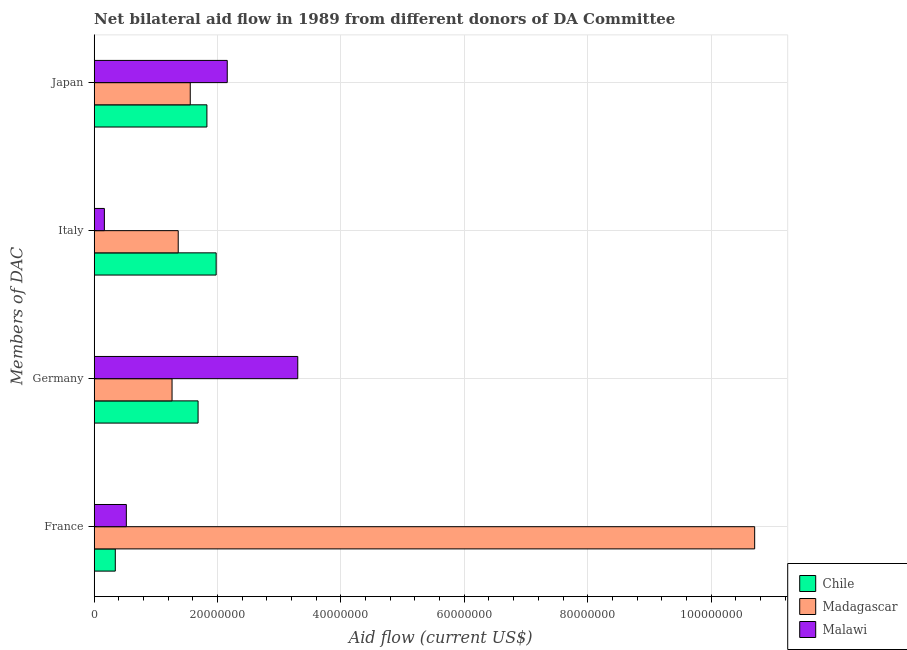Are the number of bars per tick equal to the number of legend labels?
Your answer should be very brief. Yes. What is the label of the 3rd group of bars from the top?
Your answer should be very brief. Germany. What is the amount of aid given by italy in Chile?
Your answer should be very brief. 1.98e+07. Across all countries, what is the maximum amount of aid given by japan?
Your answer should be compact. 2.16e+07. Across all countries, what is the minimum amount of aid given by japan?
Give a very brief answer. 1.56e+07. In which country was the amount of aid given by germany minimum?
Make the answer very short. Madagascar. What is the total amount of aid given by germany in the graph?
Give a very brief answer. 6.25e+07. What is the difference between the amount of aid given by france in Madagascar and that in Chile?
Offer a very short reply. 1.04e+08. What is the difference between the amount of aid given by japan in Madagascar and the amount of aid given by france in Chile?
Offer a very short reply. 1.22e+07. What is the average amount of aid given by germany per country?
Your response must be concise. 2.08e+07. What is the difference between the amount of aid given by france and amount of aid given by germany in Chile?
Make the answer very short. -1.34e+07. What is the ratio of the amount of aid given by japan in Chile to that in Malawi?
Give a very brief answer. 0.85. Is the amount of aid given by germany in Madagascar less than that in Malawi?
Keep it short and to the point. Yes. Is the difference between the amount of aid given by france in Chile and Malawi greater than the difference between the amount of aid given by japan in Chile and Malawi?
Your answer should be compact. Yes. What is the difference between the highest and the second highest amount of aid given by italy?
Offer a terse response. 6.15e+06. What is the difference between the highest and the lowest amount of aid given by france?
Provide a short and direct response. 1.04e+08. Is the sum of the amount of aid given by germany in Chile and Madagascar greater than the maximum amount of aid given by france across all countries?
Make the answer very short. No. Is it the case that in every country, the sum of the amount of aid given by france and amount of aid given by germany is greater than the sum of amount of aid given by italy and amount of aid given by japan?
Provide a succinct answer. No. What does the 1st bar from the top in Germany represents?
Keep it short and to the point. Malawi. What does the 2nd bar from the bottom in Germany represents?
Ensure brevity in your answer.  Madagascar. Is it the case that in every country, the sum of the amount of aid given by france and amount of aid given by germany is greater than the amount of aid given by italy?
Your answer should be compact. Yes. How many bars are there?
Keep it short and to the point. 12. How many countries are there in the graph?
Ensure brevity in your answer.  3. What is the difference between two consecutive major ticks on the X-axis?
Your response must be concise. 2.00e+07. Does the graph contain any zero values?
Offer a terse response. No. Does the graph contain grids?
Your answer should be very brief. Yes. How many legend labels are there?
Provide a succinct answer. 3. How are the legend labels stacked?
Offer a very short reply. Vertical. What is the title of the graph?
Keep it short and to the point. Net bilateral aid flow in 1989 from different donors of DA Committee. What is the label or title of the Y-axis?
Keep it short and to the point. Members of DAC. What is the Aid flow (current US$) of Chile in France?
Provide a short and direct response. 3.42e+06. What is the Aid flow (current US$) in Madagascar in France?
Offer a terse response. 1.07e+08. What is the Aid flow (current US$) of Malawi in France?
Keep it short and to the point. 5.21e+06. What is the Aid flow (current US$) in Chile in Germany?
Ensure brevity in your answer.  1.68e+07. What is the Aid flow (current US$) of Madagascar in Germany?
Offer a very short reply. 1.26e+07. What is the Aid flow (current US$) of Malawi in Germany?
Provide a succinct answer. 3.30e+07. What is the Aid flow (current US$) in Chile in Italy?
Your answer should be compact. 1.98e+07. What is the Aid flow (current US$) in Madagascar in Italy?
Provide a short and direct response. 1.36e+07. What is the Aid flow (current US$) of Malawi in Italy?
Offer a terse response. 1.65e+06. What is the Aid flow (current US$) in Chile in Japan?
Offer a very short reply. 1.83e+07. What is the Aid flow (current US$) of Madagascar in Japan?
Your response must be concise. 1.56e+07. What is the Aid flow (current US$) of Malawi in Japan?
Provide a succinct answer. 2.16e+07. Across all Members of DAC, what is the maximum Aid flow (current US$) in Chile?
Make the answer very short. 1.98e+07. Across all Members of DAC, what is the maximum Aid flow (current US$) of Madagascar?
Make the answer very short. 1.07e+08. Across all Members of DAC, what is the maximum Aid flow (current US$) of Malawi?
Offer a terse response. 3.30e+07. Across all Members of DAC, what is the minimum Aid flow (current US$) of Chile?
Your response must be concise. 3.42e+06. Across all Members of DAC, what is the minimum Aid flow (current US$) in Madagascar?
Your answer should be compact. 1.26e+07. Across all Members of DAC, what is the minimum Aid flow (current US$) of Malawi?
Ensure brevity in your answer.  1.65e+06. What is the total Aid flow (current US$) of Chile in the graph?
Ensure brevity in your answer.  5.83e+07. What is the total Aid flow (current US$) of Madagascar in the graph?
Make the answer very short. 1.49e+08. What is the total Aid flow (current US$) in Malawi in the graph?
Your answer should be compact. 6.14e+07. What is the difference between the Aid flow (current US$) in Chile in France and that in Germany?
Provide a short and direct response. -1.34e+07. What is the difference between the Aid flow (current US$) in Madagascar in France and that in Germany?
Give a very brief answer. 9.44e+07. What is the difference between the Aid flow (current US$) of Malawi in France and that in Germany?
Offer a very short reply. -2.78e+07. What is the difference between the Aid flow (current US$) in Chile in France and that in Italy?
Ensure brevity in your answer.  -1.64e+07. What is the difference between the Aid flow (current US$) in Madagascar in France and that in Italy?
Offer a terse response. 9.34e+07. What is the difference between the Aid flow (current US$) of Malawi in France and that in Italy?
Your answer should be compact. 3.56e+06. What is the difference between the Aid flow (current US$) in Chile in France and that in Japan?
Your response must be concise. -1.48e+07. What is the difference between the Aid flow (current US$) in Madagascar in France and that in Japan?
Make the answer very short. 9.15e+07. What is the difference between the Aid flow (current US$) of Malawi in France and that in Japan?
Keep it short and to the point. -1.64e+07. What is the difference between the Aid flow (current US$) of Chile in Germany and that in Italy?
Offer a terse response. -2.93e+06. What is the difference between the Aid flow (current US$) of Malawi in Germany and that in Italy?
Your answer should be very brief. 3.14e+07. What is the difference between the Aid flow (current US$) in Chile in Germany and that in Japan?
Your answer should be very brief. -1.43e+06. What is the difference between the Aid flow (current US$) of Madagascar in Germany and that in Japan?
Provide a short and direct response. -2.95e+06. What is the difference between the Aid flow (current US$) in Malawi in Germany and that in Japan?
Offer a terse response. 1.14e+07. What is the difference between the Aid flow (current US$) in Chile in Italy and that in Japan?
Give a very brief answer. 1.50e+06. What is the difference between the Aid flow (current US$) of Madagascar in Italy and that in Japan?
Your answer should be compact. -1.95e+06. What is the difference between the Aid flow (current US$) in Malawi in Italy and that in Japan?
Provide a succinct answer. -1.99e+07. What is the difference between the Aid flow (current US$) in Chile in France and the Aid flow (current US$) in Madagascar in Germany?
Keep it short and to the point. -9.20e+06. What is the difference between the Aid flow (current US$) in Chile in France and the Aid flow (current US$) in Malawi in Germany?
Give a very brief answer. -2.96e+07. What is the difference between the Aid flow (current US$) of Madagascar in France and the Aid flow (current US$) of Malawi in Germany?
Give a very brief answer. 7.41e+07. What is the difference between the Aid flow (current US$) of Chile in France and the Aid flow (current US$) of Madagascar in Italy?
Make the answer very short. -1.02e+07. What is the difference between the Aid flow (current US$) of Chile in France and the Aid flow (current US$) of Malawi in Italy?
Provide a short and direct response. 1.77e+06. What is the difference between the Aid flow (current US$) of Madagascar in France and the Aid flow (current US$) of Malawi in Italy?
Give a very brief answer. 1.05e+08. What is the difference between the Aid flow (current US$) of Chile in France and the Aid flow (current US$) of Madagascar in Japan?
Keep it short and to the point. -1.22e+07. What is the difference between the Aid flow (current US$) of Chile in France and the Aid flow (current US$) of Malawi in Japan?
Offer a very short reply. -1.82e+07. What is the difference between the Aid flow (current US$) in Madagascar in France and the Aid flow (current US$) in Malawi in Japan?
Offer a very short reply. 8.55e+07. What is the difference between the Aid flow (current US$) in Chile in Germany and the Aid flow (current US$) in Madagascar in Italy?
Give a very brief answer. 3.22e+06. What is the difference between the Aid flow (current US$) in Chile in Germany and the Aid flow (current US$) in Malawi in Italy?
Your answer should be very brief. 1.52e+07. What is the difference between the Aid flow (current US$) in Madagascar in Germany and the Aid flow (current US$) in Malawi in Italy?
Provide a short and direct response. 1.10e+07. What is the difference between the Aid flow (current US$) in Chile in Germany and the Aid flow (current US$) in Madagascar in Japan?
Provide a short and direct response. 1.27e+06. What is the difference between the Aid flow (current US$) in Chile in Germany and the Aid flow (current US$) in Malawi in Japan?
Your answer should be compact. -4.73e+06. What is the difference between the Aid flow (current US$) in Madagascar in Germany and the Aid flow (current US$) in Malawi in Japan?
Your response must be concise. -8.95e+06. What is the difference between the Aid flow (current US$) of Chile in Italy and the Aid flow (current US$) of Madagascar in Japan?
Your answer should be very brief. 4.20e+06. What is the difference between the Aid flow (current US$) of Chile in Italy and the Aid flow (current US$) of Malawi in Japan?
Ensure brevity in your answer.  -1.80e+06. What is the difference between the Aid flow (current US$) of Madagascar in Italy and the Aid flow (current US$) of Malawi in Japan?
Offer a terse response. -7.95e+06. What is the average Aid flow (current US$) in Chile per Members of DAC?
Give a very brief answer. 1.46e+07. What is the average Aid flow (current US$) in Madagascar per Members of DAC?
Offer a very short reply. 3.72e+07. What is the average Aid flow (current US$) in Malawi per Members of DAC?
Your response must be concise. 1.54e+07. What is the difference between the Aid flow (current US$) in Chile and Aid flow (current US$) in Madagascar in France?
Your answer should be very brief. -1.04e+08. What is the difference between the Aid flow (current US$) in Chile and Aid flow (current US$) in Malawi in France?
Make the answer very short. -1.79e+06. What is the difference between the Aid flow (current US$) in Madagascar and Aid flow (current US$) in Malawi in France?
Provide a short and direct response. 1.02e+08. What is the difference between the Aid flow (current US$) of Chile and Aid flow (current US$) of Madagascar in Germany?
Offer a very short reply. 4.22e+06. What is the difference between the Aid flow (current US$) of Chile and Aid flow (current US$) of Malawi in Germany?
Make the answer very short. -1.62e+07. What is the difference between the Aid flow (current US$) of Madagascar and Aid flow (current US$) of Malawi in Germany?
Ensure brevity in your answer.  -2.04e+07. What is the difference between the Aid flow (current US$) of Chile and Aid flow (current US$) of Madagascar in Italy?
Ensure brevity in your answer.  6.15e+06. What is the difference between the Aid flow (current US$) of Chile and Aid flow (current US$) of Malawi in Italy?
Keep it short and to the point. 1.81e+07. What is the difference between the Aid flow (current US$) of Madagascar and Aid flow (current US$) of Malawi in Italy?
Offer a terse response. 1.20e+07. What is the difference between the Aid flow (current US$) in Chile and Aid flow (current US$) in Madagascar in Japan?
Provide a succinct answer. 2.70e+06. What is the difference between the Aid flow (current US$) in Chile and Aid flow (current US$) in Malawi in Japan?
Provide a succinct answer. -3.30e+06. What is the difference between the Aid flow (current US$) in Madagascar and Aid flow (current US$) in Malawi in Japan?
Offer a very short reply. -6.00e+06. What is the ratio of the Aid flow (current US$) of Chile in France to that in Germany?
Keep it short and to the point. 0.2. What is the ratio of the Aid flow (current US$) of Madagascar in France to that in Germany?
Keep it short and to the point. 8.48. What is the ratio of the Aid flow (current US$) in Malawi in France to that in Germany?
Your answer should be compact. 0.16. What is the ratio of the Aid flow (current US$) in Chile in France to that in Italy?
Provide a short and direct response. 0.17. What is the ratio of the Aid flow (current US$) of Madagascar in France to that in Italy?
Provide a succinct answer. 7.86. What is the ratio of the Aid flow (current US$) in Malawi in France to that in Italy?
Keep it short and to the point. 3.16. What is the ratio of the Aid flow (current US$) in Chile in France to that in Japan?
Offer a very short reply. 0.19. What is the ratio of the Aid flow (current US$) of Madagascar in France to that in Japan?
Ensure brevity in your answer.  6.88. What is the ratio of the Aid flow (current US$) in Malawi in France to that in Japan?
Your answer should be compact. 0.24. What is the ratio of the Aid flow (current US$) in Chile in Germany to that in Italy?
Offer a terse response. 0.85. What is the ratio of the Aid flow (current US$) in Madagascar in Germany to that in Italy?
Your answer should be very brief. 0.93. What is the ratio of the Aid flow (current US$) in Malawi in Germany to that in Italy?
Your answer should be very brief. 20. What is the ratio of the Aid flow (current US$) in Chile in Germany to that in Japan?
Make the answer very short. 0.92. What is the ratio of the Aid flow (current US$) of Madagascar in Germany to that in Japan?
Make the answer very short. 0.81. What is the ratio of the Aid flow (current US$) of Malawi in Germany to that in Japan?
Keep it short and to the point. 1.53. What is the ratio of the Aid flow (current US$) of Chile in Italy to that in Japan?
Provide a short and direct response. 1.08. What is the ratio of the Aid flow (current US$) of Madagascar in Italy to that in Japan?
Provide a succinct answer. 0.87. What is the ratio of the Aid flow (current US$) of Malawi in Italy to that in Japan?
Your answer should be very brief. 0.08. What is the difference between the highest and the second highest Aid flow (current US$) of Chile?
Offer a very short reply. 1.50e+06. What is the difference between the highest and the second highest Aid flow (current US$) of Madagascar?
Keep it short and to the point. 9.15e+07. What is the difference between the highest and the second highest Aid flow (current US$) in Malawi?
Give a very brief answer. 1.14e+07. What is the difference between the highest and the lowest Aid flow (current US$) of Chile?
Your response must be concise. 1.64e+07. What is the difference between the highest and the lowest Aid flow (current US$) of Madagascar?
Your answer should be very brief. 9.44e+07. What is the difference between the highest and the lowest Aid flow (current US$) in Malawi?
Ensure brevity in your answer.  3.14e+07. 